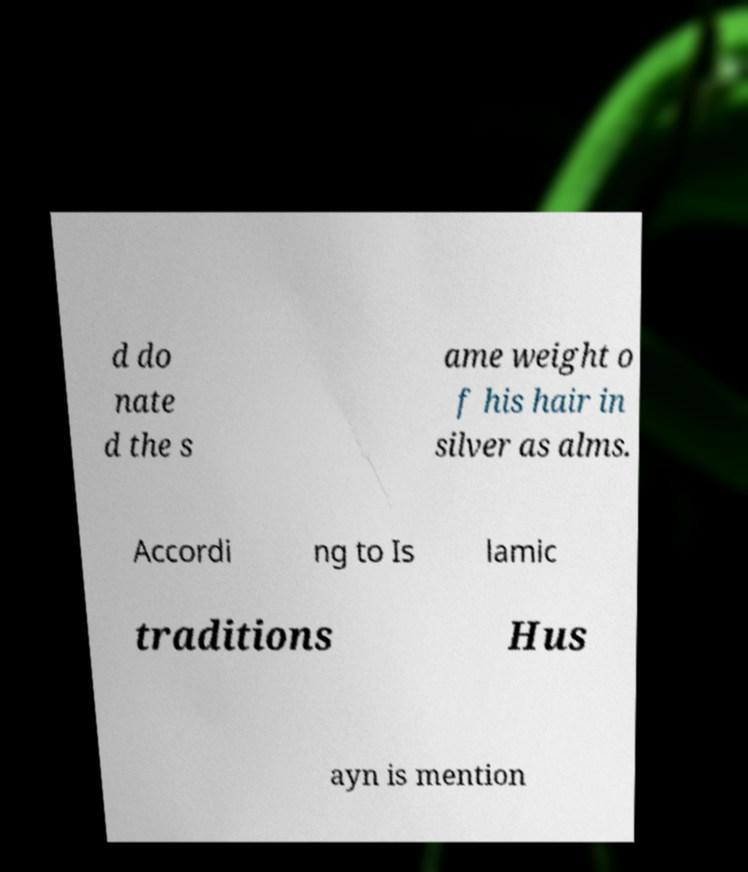Can you read and provide the text displayed in the image?This photo seems to have some interesting text. Can you extract and type it out for me? d do nate d the s ame weight o f his hair in silver as alms. Accordi ng to Is lamic traditions Hus ayn is mention 